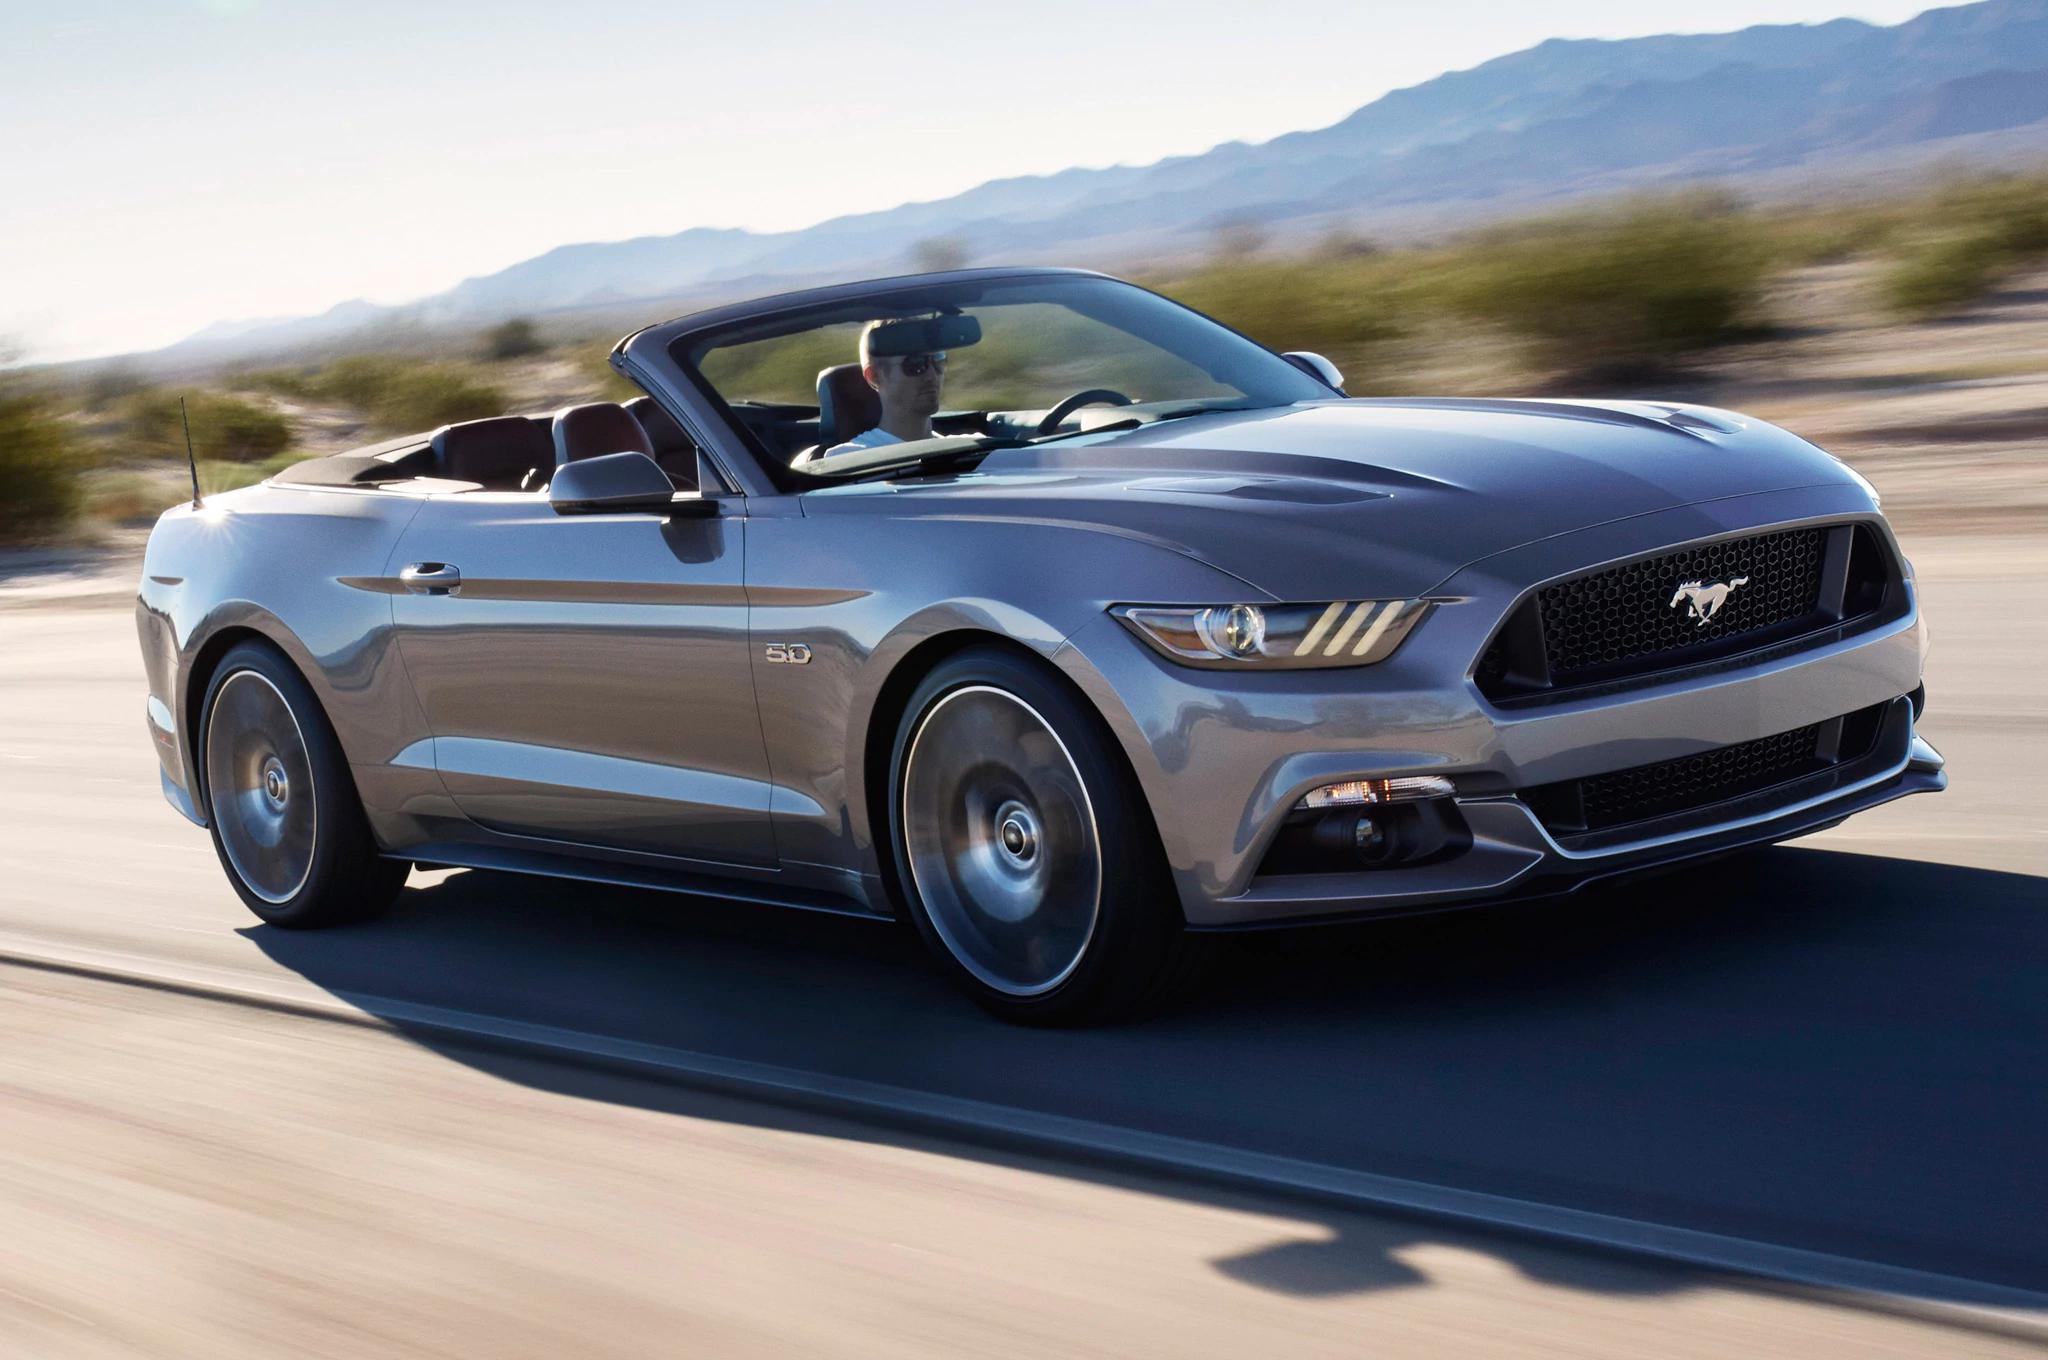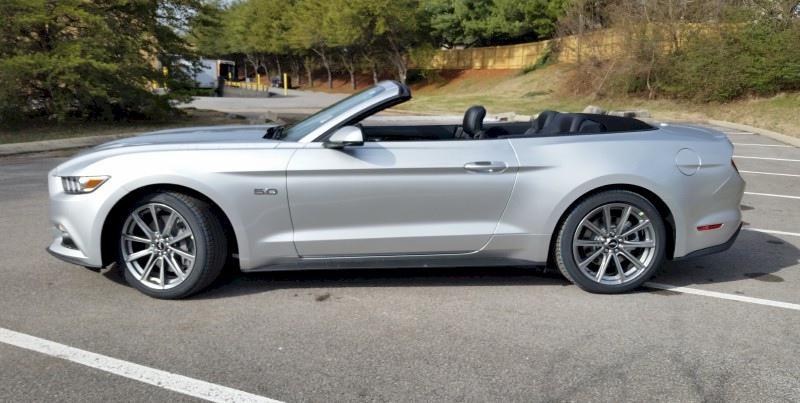The first image is the image on the left, the second image is the image on the right. For the images displayed, is the sentence "One convertible is angled towards the front and one is shown from the side." factually correct? Answer yes or no. Yes. The first image is the image on the left, the second image is the image on the right. Assess this claim about the two images: "All cars are facing left.". Correct or not? Answer yes or no. No. 